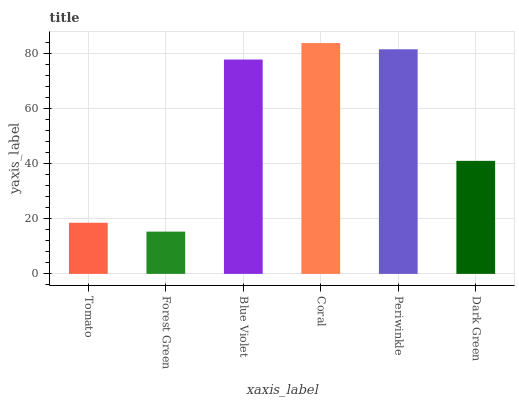Is Forest Green the minimum?
Answer yes or no. Yes. Is Coral the maximum?
Answer yes or no. Yes. Is Blue Violet the minimum?
Answer yes or no. No. Is Blue Violet the maximum?
Answer yes or no. No. Is Blue Violet greater than Forest Green?
Answer yes or no. Yes. Is Forest Green less than Blue Violet?
Answer yes or no. Yes. Is Forest Green greater than Blue Violet?
Answer yes or no. No. Is Blue Violet less than Forest Green?
Answer yes or no. No. Is Blue Violet the high median?
Answer yes or no. Yes. Is Dark Green the low median?
Answer yes or no. Yes. Is Coral the high median?
Answer yes or no. No. Is Tomato the low median?
Answer yes or no. No. 